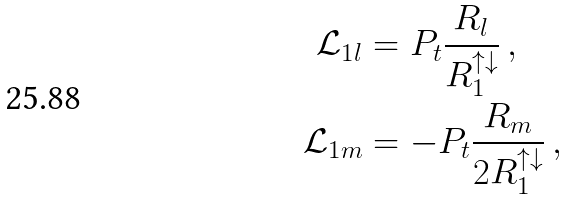Convert formula to latex. <formula><loc_0><loc_0><loc_500><loc_500>\mathcal { L } _ { 1 l } & = P _ { t } \frac { R _ { l } } { R _ { 1 } ^ { \uparrow \downarrow } } \, , \\ \mathcal { L } _ { 1 m } & = - P _ { t } \frac { R _ { m } } { 2 R _ { 1 } ^ { \uparrow \downarrow } } \, ,</formula> 